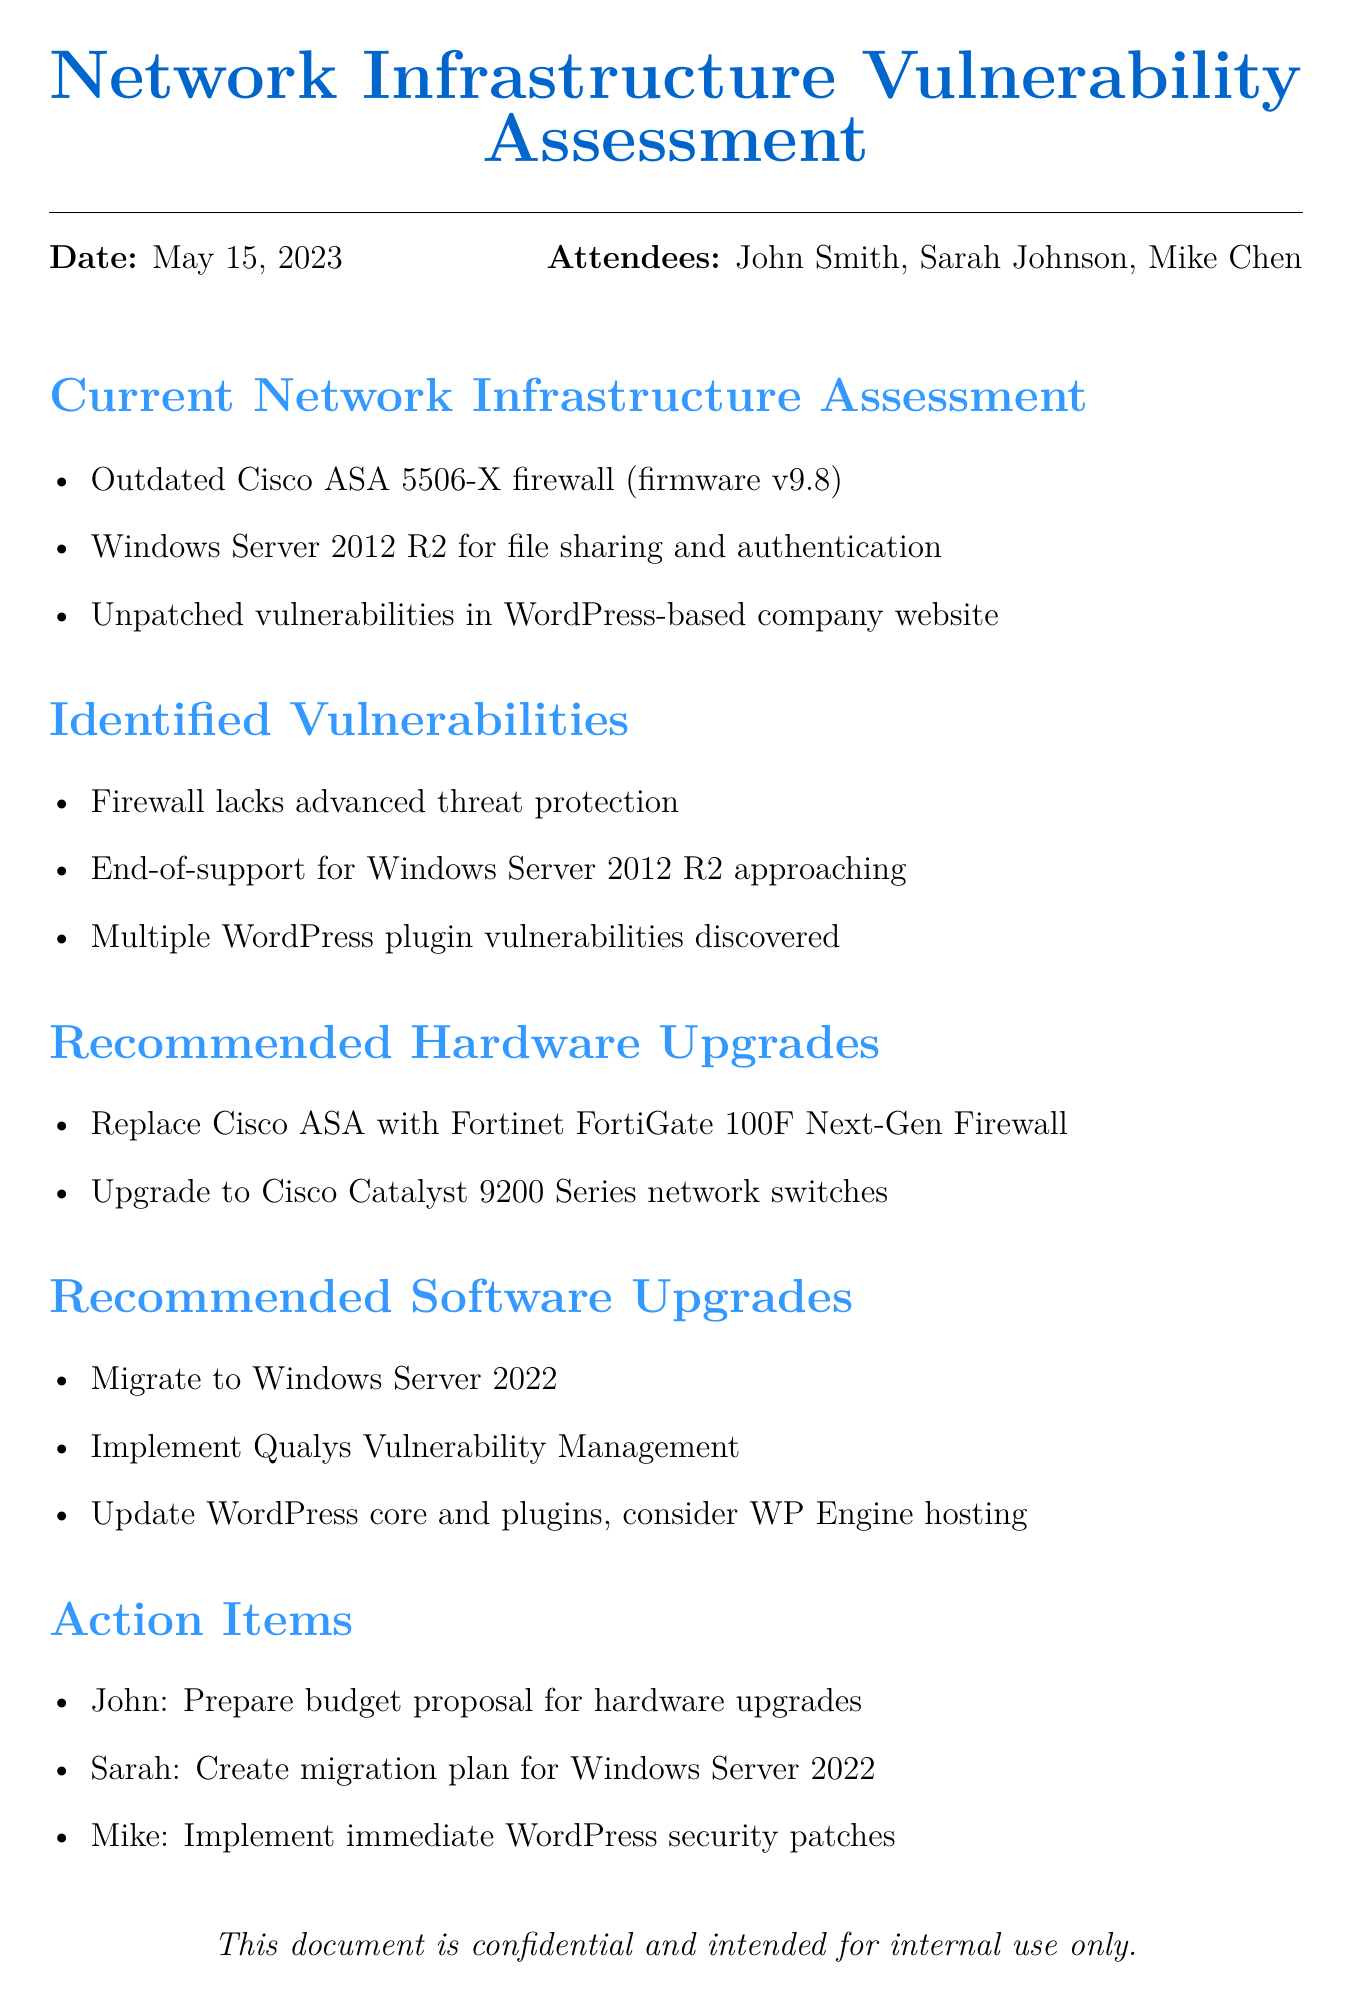What is the date of the meeting? The date of the meeting is specified clearly at the beginning of the document.
Answer: May 15, 2023 Who is responsible for preparing the budget proposal? The action item indicates that John is the one tasked with this responsibility.
Answer: John What outdated hardware was mentioned in the assessment? The assessment lists specific hardware that is outdated, which includes the Cisco ASA 5506-X firewall.
Answer: Cisco ASA 5506-X What is the recommended next-generation firewall? The document specifies the recommended hardware upgrade for the firewall.
Answer: Fortinet FortiGate 100F Why should Windows Server 2012 R2 be upgraded? The vulnerabilities highlighted indicate that it is approaching end-of-support, necessitating an upgrade for better security.
Answer: End-of-support What software is recommended for continuous network scanning? A specific software tool is mentioned in the recommendations for software upgrades.
Answer: Qualys Vulnerability Management 